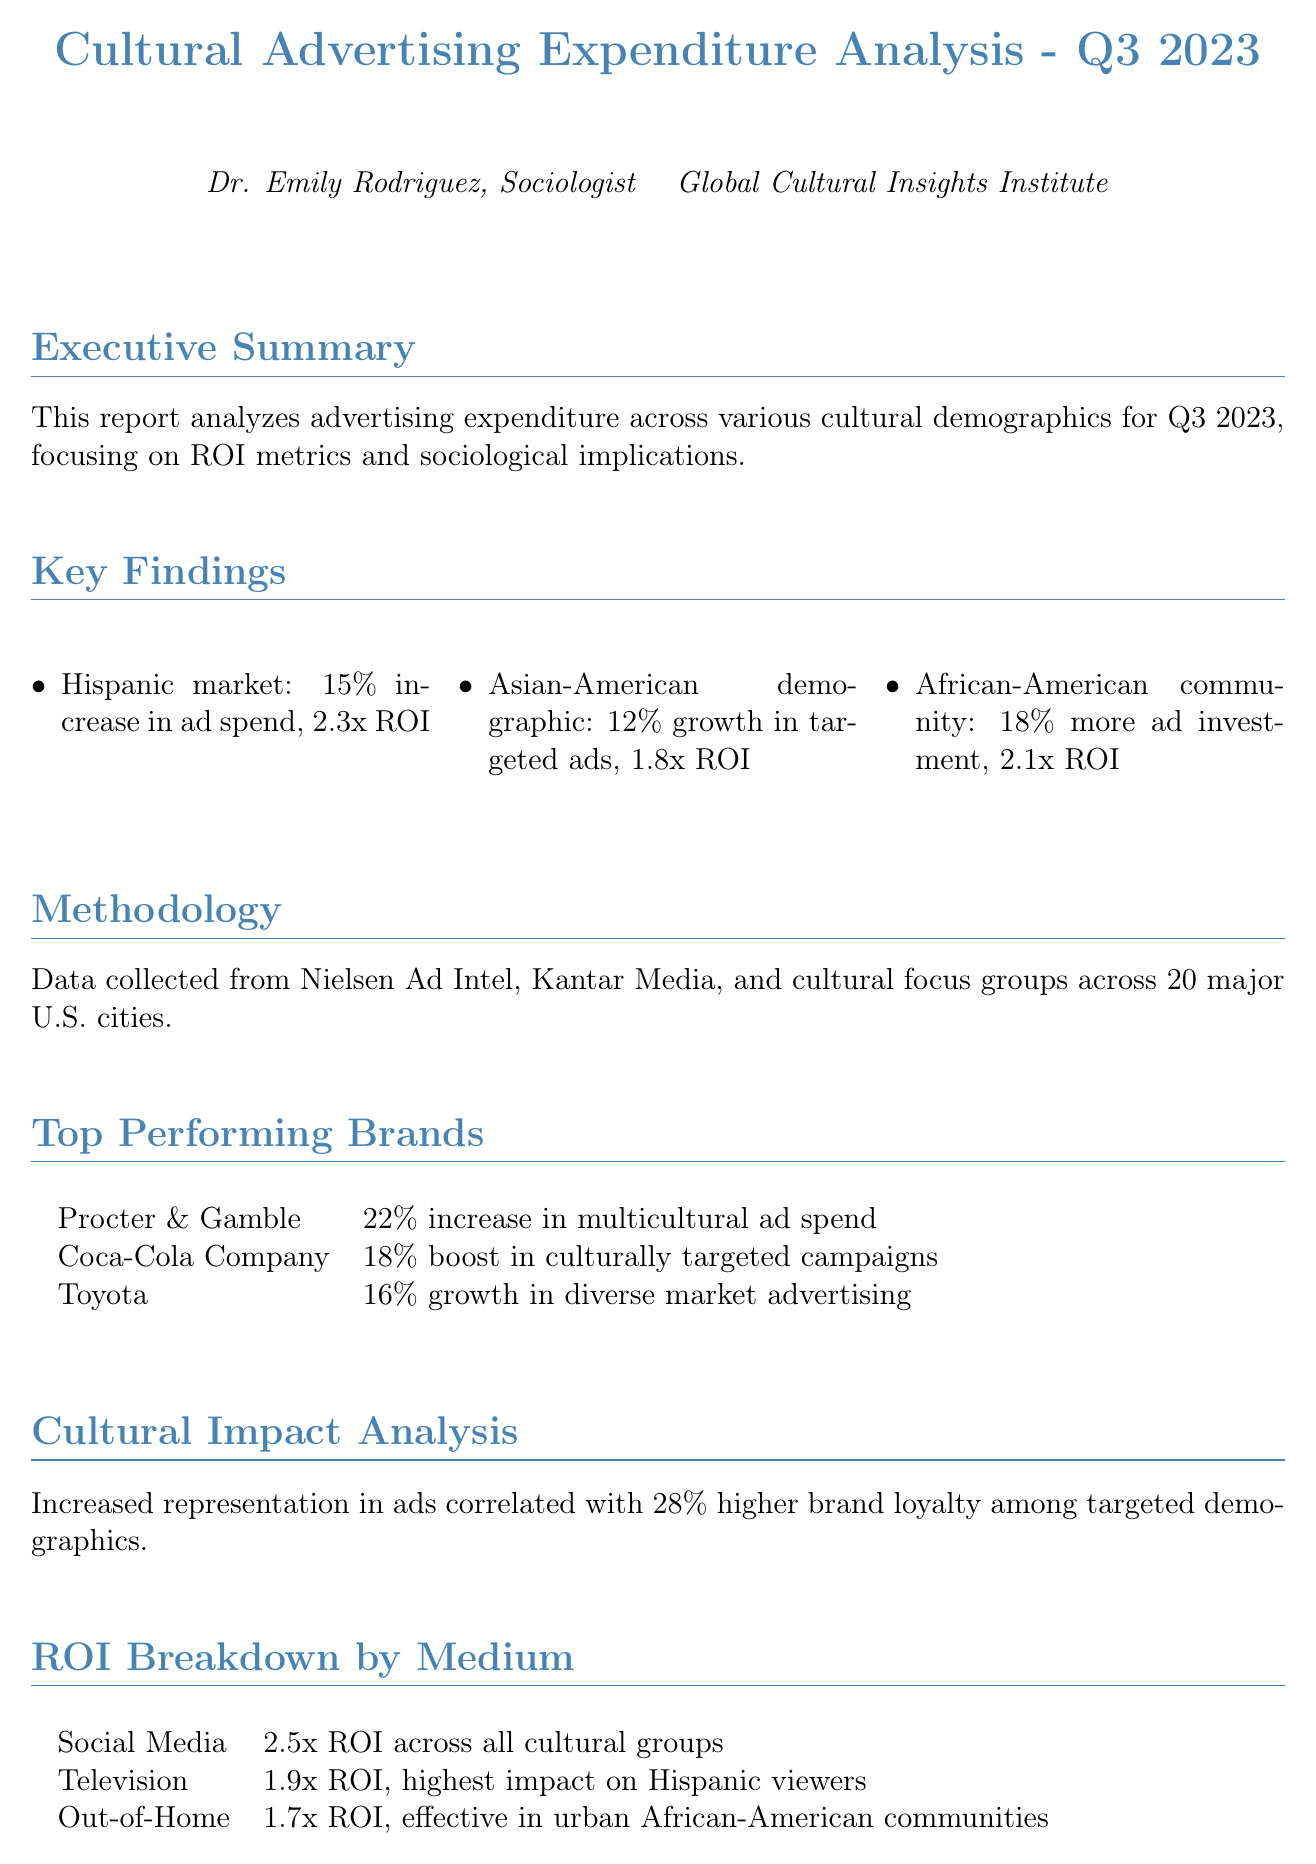What is the title of the report? The title of the report is stated at the beginning of the document.
Answer: Cultural Advertising Expenditure Analysis - Q3 2023 Who authored the report? The author of the report is mentioned in the author section.
Answer: Dr. Emily Rodriguez What was the ROI for the Asian-American demographic? ROI for this demographic is found in the key findings section of the report.
Answer: 1.8x ROI Which medium had the highest ROI across all cultural groups? The ROI breakdown by medium provides information on which medium had the highest ROI.
Answer: Social Media What percentage did the Hispanic market increase in ad spend? This information is found under the key findings section concerning the Hispanic market.
Answer: 15% What correlation was found between increased representation in ads and brand loyalty? This information is part of the cultural impact analysis.
Answer: 28% higher brand loyalty Which brand had a 22% increase in multicultural ad spend? This data is included in the top performing brands section.
Answer: Procter & Gamble What is the anticipated growth in multicultural ad spend for Q4 2023? The future projections section provides this anticipated growth information.
Answer: 20% growth 